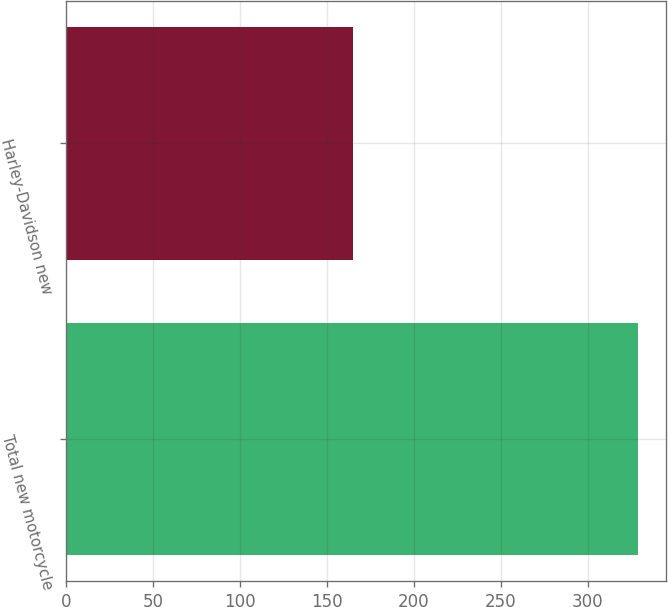Convert chart to OTSL. <chart><loc_0><loc_0><loc_500><loc_500><bar_chart><fcel>Total new motorcycle<fcel>Harley-Davidson new<nl><fcel>328.8<fcel>165.1<nl></chart> 